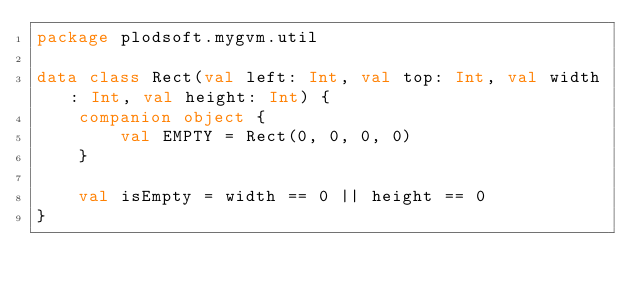Convert code to text. <code><loc_0><loc_0><loc_500><loc_500><_Kotlin_>package plodsoft.mygvm.util

data class Rect(val left: Int, val top: Int, val width: Int, val height: Int) {
    companion object {
        val EMPTY = Rect(0, 0, 0, 0)
    }

    val isEmpty = width == 0 || height == 0
}</code> 